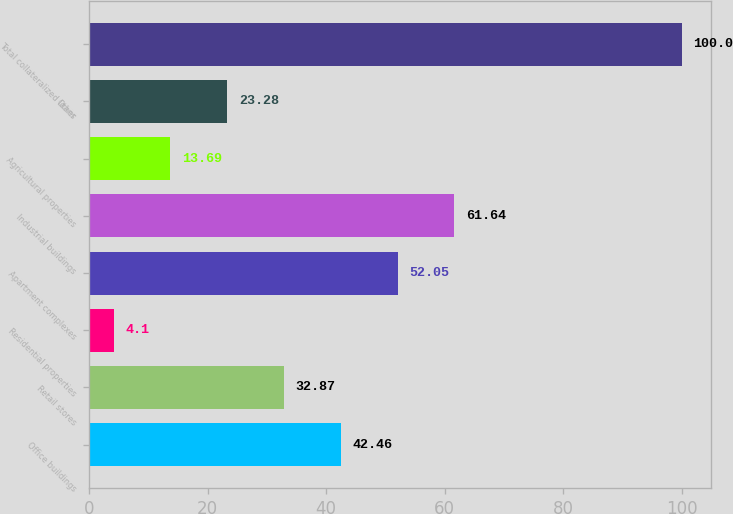<chart> <loc_0><loc_0><loc_500><loc_500><bar_chart><fcel>Office buildings<fcel>Retail stores<fcel>Residential properties<fcel>Apartment complexes<fcel>Industrial buildings<fcel>Agricultural properties<fcel>Other<fcel>Total collateralized loans<nl><fcel>42.46<fcel>32.87<fcel>4.1<fcel>52.05<fcel>61.64<fcel>13.69<fcel>23.28<fcel>100<nl></chart> 